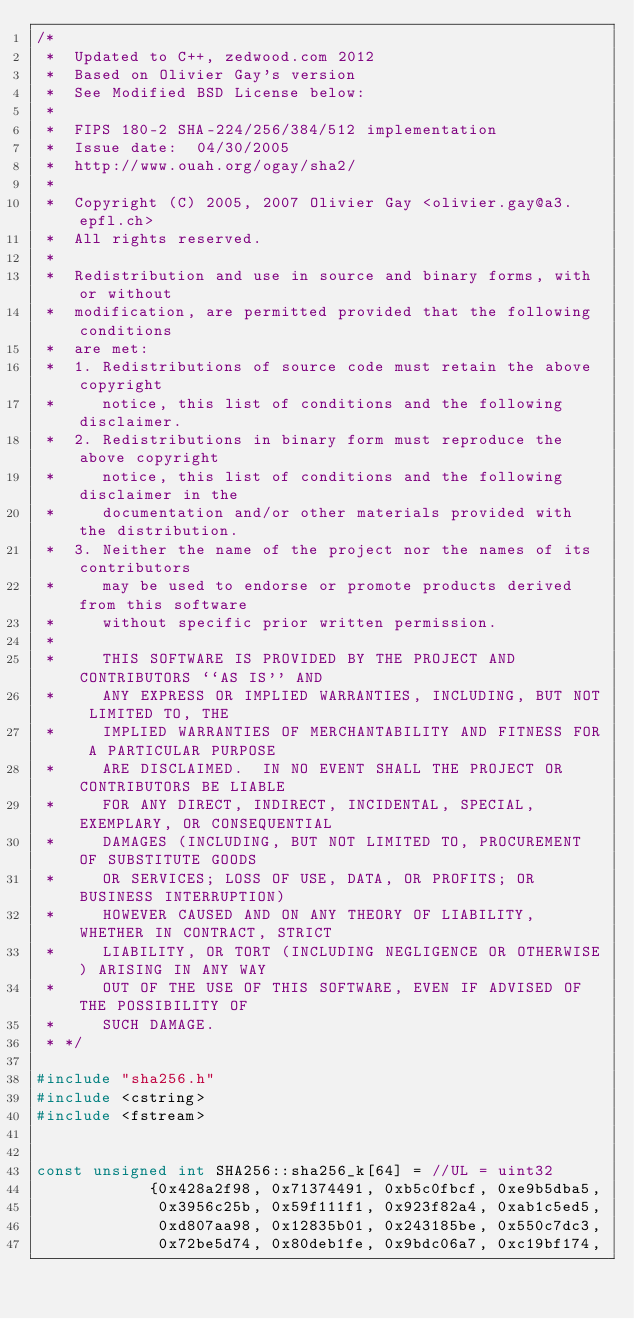<code> <loc_0><loc_0><loc_500><loc_500><_C++_>/*
 *  Updated to C++, zedwood.com 2012
 *  Based on Olivier Gay's version
 *  See Modified BSD License below: 
 *  
 *  FIPS 180-2 SHA-224/256/384/512 implementation
 *  Issue date:  04/30/2005
 *  http://www.ouah.org/ogay/sha2/
 *  
 *  Copyright (C) 2005, 2007 Olivier Gay <olivier.gay@a3.epfl.ch>
 *  All rights reserved.
 *  
 *  Redistribution and use in source and binary forms, with or without
 *  modification, are permitted provided that the following conditions
 *  are met:
 *  1. Redistributions of source code must retain the above copyright
 *     notice, this list of conditions and the following disclaimer.
 *  2. Redistributions in binary form must reproduce the above copyright
 *     notice, this list of conditions and the following disclaimer in the
 *     documentation and/or other materials provided with the distribution.
 *  3. Neither the name of the project nor the names of its contributors
 *     may be used to endorse or promote products derived from this software
 *     without specific prior written permission.
 *     
 *     THIS SOFTWARE IS PROVIDED BY THE PROJECT AND CONTRIBUTORS ``AS IS'' AND
 *     ANY EXPRESS OR IMPLIED WARRANTIES, INCLUDING, BUT NOT LIMITED TO, THE
 *     IMPLIED WARRANTIES OF MERCHANTABILITY AND FITNESS FOR A PARTICULAR PURPOSE
 *     ARE DISCLAIMED.  IN NO EVENT SHALL THE PROJECT OR CONTRIBUTORS BE LIABLE
 *     FOR ANY DIRECT, INDIRECT, INCIDENTAL, SPECIAL, EXEMPLARY, OR CONSEQUENTIAL
 *     DAMAGES (INCLUDING, BUT NOT LIMITED TO, PROCUREMENT OF SUBSTITUTE GOODS
 *     OR SERVICES; LOSS OF USE, DATA, OR PROFITS; OR BUSINESS INTERRUPTION)
 *     HOWEVER CAUSED AND ON ANY THEORY OF LIABILITY, WHETHER IN CONTRACT, STRICT
 *     LIABILITY, OR TORT (INCLUDING NEGLIGENCE OR OTHERWISE) ARISING IN ANY WAY
 *     OUT OF THE USE OF THIS SOFTWARE, EVEN IF ADVISED OF THE POSSIBILITY OF
 *     SUCH DAMAGE.
 * */

#include "sha256.h"
#include <cstring>
#include <fstream>

 
const unsigned int SHA256::sha256_k[64] = //UL = uint32
            {0x428a2f98, 0x71374491, 0xb5c0fbcf, 0xe9b5dba5,
             0x3956c25b, 0x59f111f1, 0x923f82a4, 0xab1c5ed5,
             0xd807aa98, 0x12835b01, 0x243185be, 0x550c7dc3,
             0x72be5d74, 0x80deb1fe, 0x9bdc06a7, 0xc19bf174,</code> 